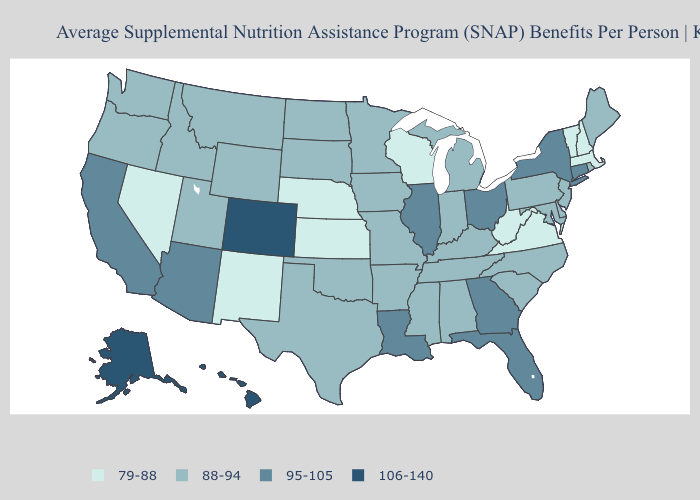Does Nebraska have a lower value than New Mexico?
Answer briefly. No. Which states have the lowest value in the Northeast?
Concise answer only. Massachusetts, New Hampshire, Vermont. Does Colorado have the highest value in the USA?
Short answer required. Yes. Is the legend a continuous bar?
Short answer required. No. Name the states that have a value in the range 106-140?
Answer briefly. Alaska, Colorado, Hawaii. What is the highest value in the USA?
Be succinct. 106-140. Name the states that have a value in the range 106-140?
Quick response, please. Alaska, Colorado, Hawaii. Does Connecticut have the lowest value in the USA?
Write a very short answer. No. What is the highest value in the West ?
Short answer required. 106-140. What is the value of Massachusetts?
Keep it brief. 79-88. What is the value of Connecticut?
Short answer required. 95-105. Among the states that border Montana , which have the highest value?
Quick response, please. Idaho, North Dakota, South Dakota, Wyoming. Among the states that border Alabama , does Mississippi have the lowest value?
Answer briefly. Yes. Among the states that border Wyoming , which have the highest value?
Give a very brief answer. Colorado. Name the states that have a value in the range 95-105?
Write a very short answer. Arizona, California, Connecticut, Florida, Georgia, Illinois, Louisiana, New York, Ohio. 